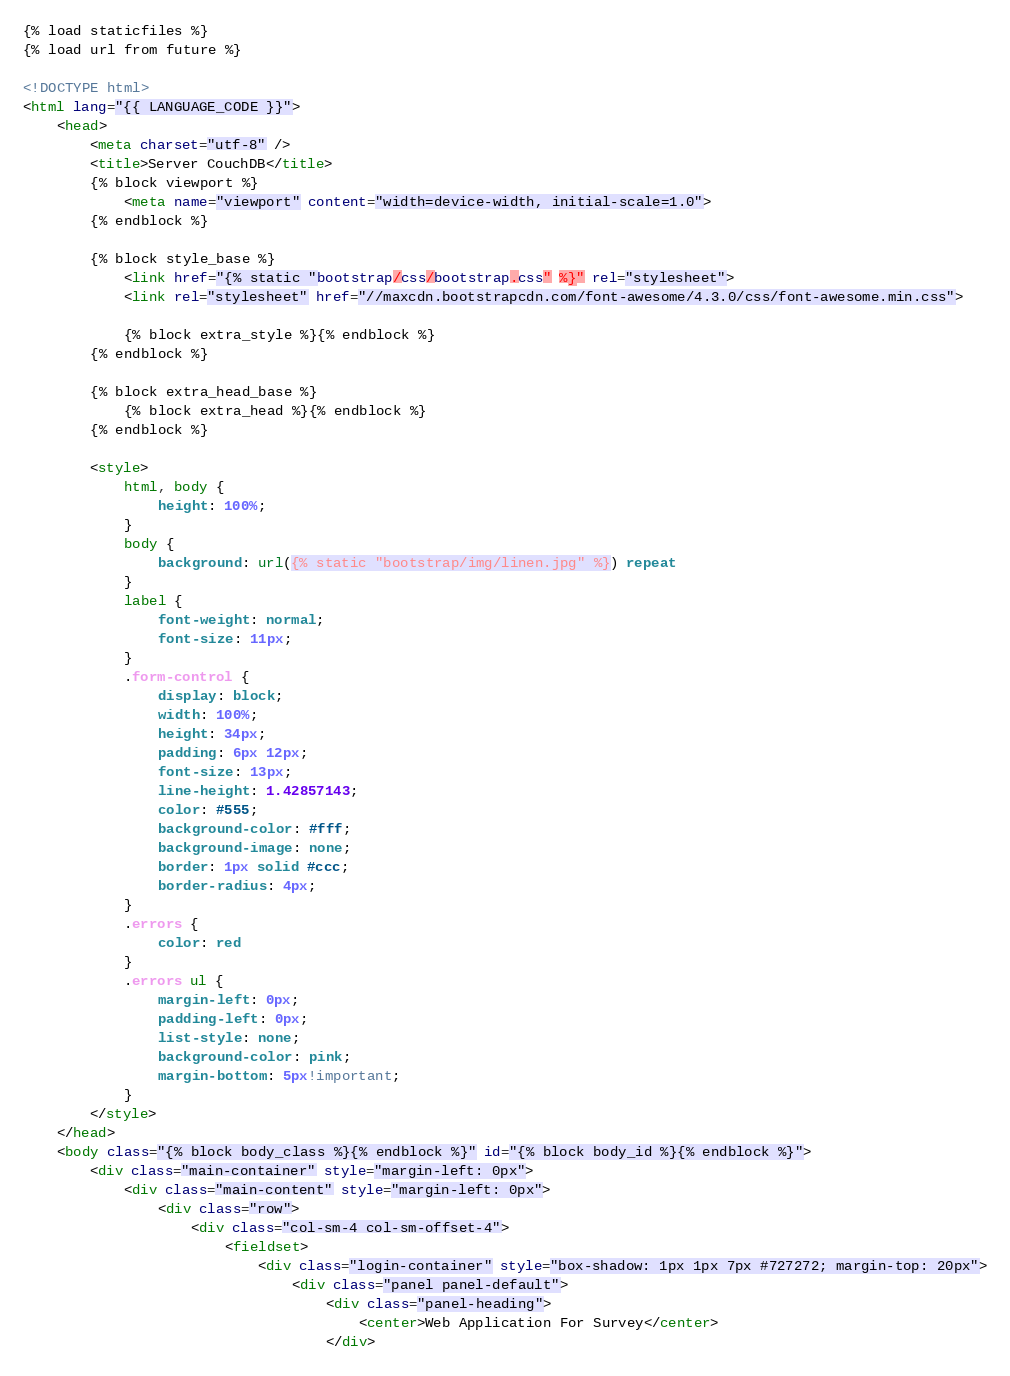Convert code to text. <code><loc_0><loc_0><loc_500><loc_500><_HTML_>{% load staticfiles %}
{% load url from future %}

<!DOCTYPE html>
<html lang="{{ LANGUAGE_CODE }}">
	<head>
		<meta charset="utf-8" />
		<title>Server CouchDB</title>
		{% block viewport %}
			<meta name="viewport" content="width=device-width, initial-scale=1.0">
		{% endblock %}

		{% block style_base %}
			<link href="{% static "bootstrap/css/bootstrap.css" %}" rel="stylesheet">
			<link rel="stylesheet" href="//maxcdn.bootstrapcdn.com/font-awesome/4.3.0/css/font-awesome.min.css">

			{% block extra_style %}{% endblock %}
		{% endblock %}

		{% block extra_head_base %}
			{% block extra_head %}{% endblock %}
		{% endblock %}

		<style>
			html, body {
				height: 100%;
			}
			body {
				background: url({% static "bootstrap/img/linen.jpg" %}) repeat
			}
			label {
				font-weight: normal;
				font-size: 11px;
			}
			.form-control {
				display: block;
				width: 100%;
				height: 34px;
				padding: 6px 12px;
				font-size: 13px;
				line-height: 1.42857143;
				color: #555;
				background-color: #fff;
				background-image: none;
				border: 1px solid #ccc;
				border-radius: 4px;
			}
			.errors {
				color: red
			}
			.errors ul {
				margin-left: 0px;
				padding-left: 0px;
				list-style: none;
				background-color: pink;
				margin-bottom: 5px!important;
			}
		</style>
	</head>
	<body class="{% block body_class %}{% endblock %}" id="{% block body_id %}{% endblock %}">
		<div class="main-container" style="margin-left: 0px">
			<div class="main-content" style="margin-left: 0px">
				<div class="row">
					<div class="col-sm-4 col-sm-offset-4">
						<fieldset>
							<div class="login-container" style="box-shadow: 1px 1px 7px #727272; margin-top: 20px">
								<div class="panel panel-default">
									<div class="panel-heading">
										<center>Web Application For Survey</center>
									</div></code> 